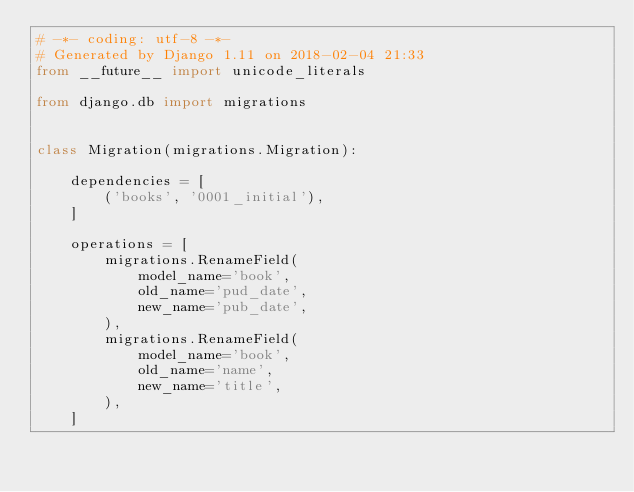Convert code to text. <code><loc_0><loc_0><loc_500><loc_500><_Python_># -*- coding: utf-8 -*-
# Generated by Django 1.11 on 2018-02-04 21:33
from __future__ import unicode_literals

from django.db import migrations


class Migration(migrations.Migration):

    dependencies = [
        ('books', '0001_initial'),
    ]

    operations = [
        migrations.RenameField(
            model_name='book',
            old_name='pud_date',
            new_name='pub_date',
        ),
        migrations.RenameField(
            model_name='book',
            old_name='name',
            new_name='title',
        ),
    ]
</code> 